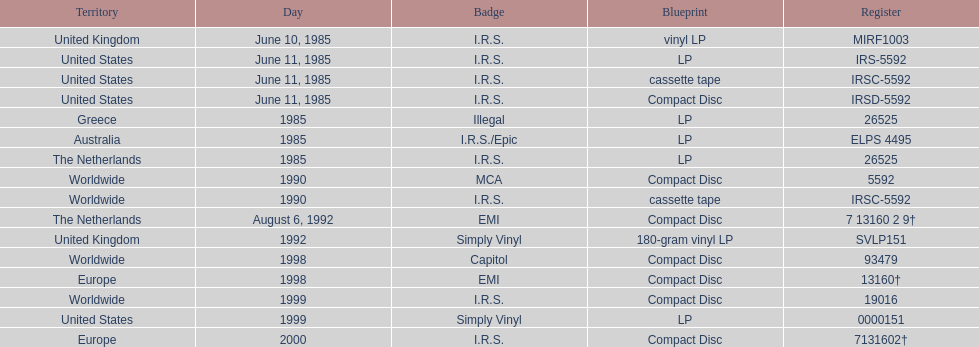In how many countries was the album released before 1990? 5. 